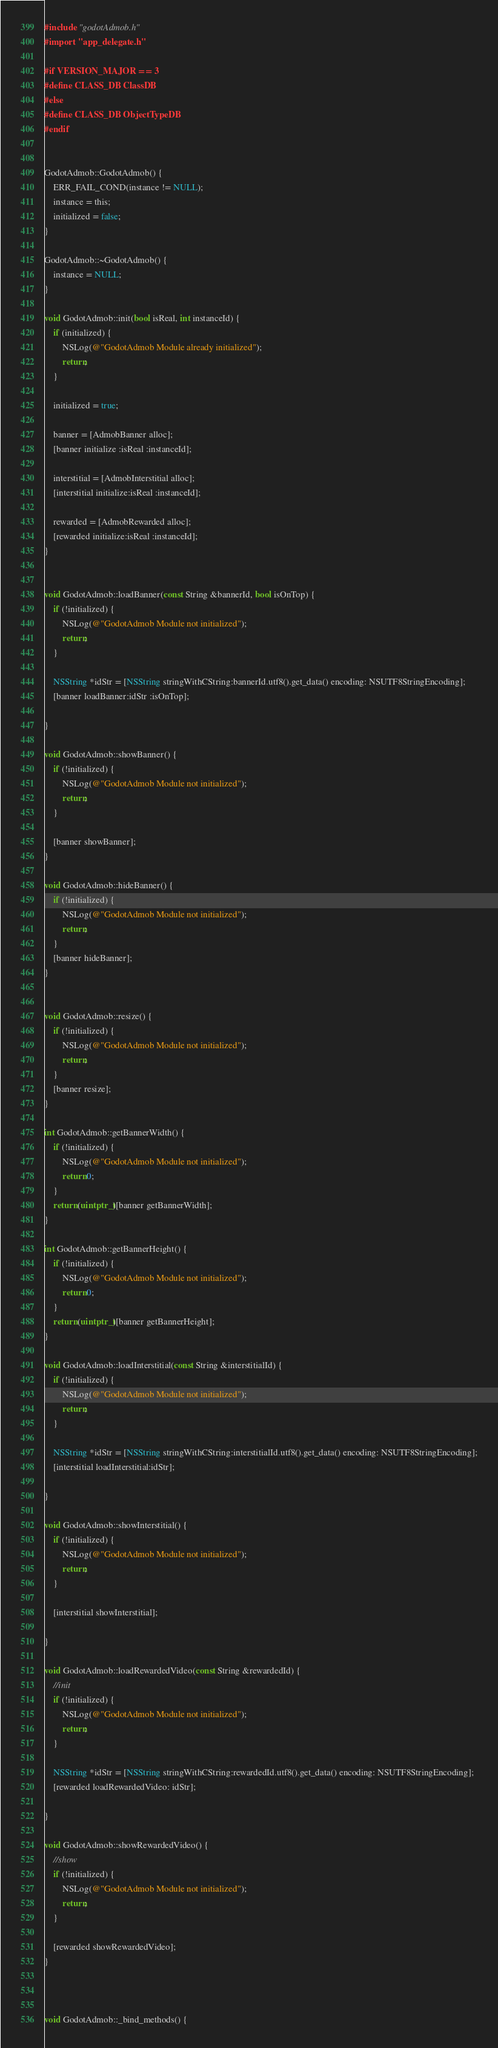<code> <loc_0><loc_0><loc_500><loc_500><_ObjectiveC_>#include "godotAdmob.h"
#import "app_delegate.h"

#if VERSION_MAJOR == 3
#define CLASS_DB ClassDB
#else
#define CLASS_DB ObjectTypeDB
#endif


GodotAdmob::GodotAdmob() {
    ERR_FAIL_COND(instance != NULL);
    instance = this;
    initialized = false;
}

GodotAdmob::~GodotAdmob() {
    instance = NULL;
}

void GodotAdmob::init(bool isReal, int instanceId) {
    if (initialized) {
        NSLog(@"GodotAdmob Module already initialized");
        return;
    }
    
    initialized = true;
    
    banner = [AdmobBanner alloc];
    [banner initialize :isReal :instanceId];
    
    interstitial = [AdmobInterstitial alloc];
    [interstitial initialize:isReal :instanceId];
    
    rewarded = [AdmobRewarded alloc];
    [rewarded initialize:isReal :instanceId];
}


void GodotAdmob::loadBanner(const String &bannerId, bool isOnTop) {
    if (!initialized) {
        NSLog(@"GodotAdmob Module not initialized");
        return;
    }
    
    NSString *idStr = [NSString stringWithCString:bannerId.utf8().get_data() encoding: NSUTF8StringEncoding];
    [banner loadBanner:idStr :isOnTop];

}

void GodotAdmob::showBanner() {
    if (!initialized) {
        NSLog(@"GodotAdmob Module not initialized");
        return;
    }
    
    [banner showBanner];
}

void GodotAdmob::hideBanner() {
    if (!initialized) {
        NSLog(@"GodotAdmob Module not initialized");
        return;
    }
    [banner hideBanner];
}


void GodotAdmob::resize() {
    if (!initialized) {
        NSLog(@"GodotAdmob Module not initialized");
        return;
    }
    [banner resize];
}

int GodotAdmob::getBannerWidth() {
    if (!initialized) {
        NSLog(@"GodotAdmob Module not initialized");
        return 0;
    }
    return (uintptr_t)[banner getBannerWidth];
}

int GodotAdmob::getBannerHeight() {
    if (!initialized) {
        NSLog(@"GodotAdmob Module not initialized");
        return 0;
    }
    return (uintptr_t)[banner getBannerHeight];
}

void GodotAdmob::loadInterstitial(const String &interstitialId) {
    if (!initialized) {
        NSLog(@"GodotAdmob Module not initialized");
        return;
    }
    
    NSString *idStr = [NSString stringWithCString:interstitialId.utf8().get_data() encoding: NSUTF8StringEncoding];
    [interstitial loadInterstitial:idStr];

}

void GodotAdmob::showInterstitial() {
    if (!initialized) {
        NSLog(@"GodotAdmob Module not initialized");
        return;
    }
    
    [interstitial showInterstitial];
    
}

void GodotAdmob::loadRewardedVideo(const String &rewardedId) {
    //init
    if (!initialized) {
        NSLog(@"GodotAdmob Module not initialized");
        return;
    }
    
    NSString *idStr = [NSString stringWithCString:rewardedId.utf8().get_data() encoding: NSUTF8StringEncoding];
    [rewarded loadRewardedVideo: idStr];
    
}

void GodotAdmob::showRewardedVideo() {
    //show
    if (!initialized) {
        NSLog(@"GodotAdmob Module not initialized");
        return;
    }
    
    [rewarded showRewardedVideo];
}



void GodotAdmob::_bind_methods() {</code> 